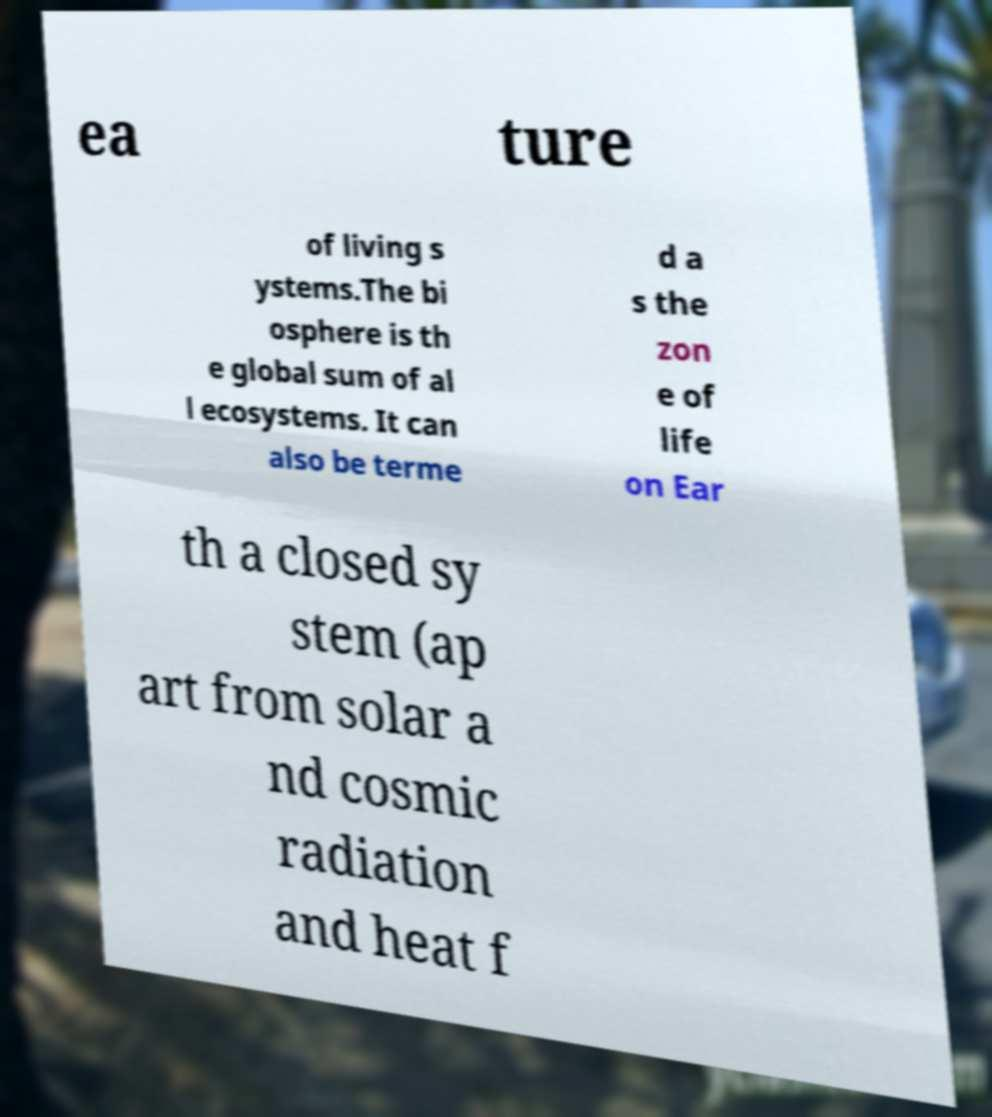I need the written content from this picture converted into text. Can you do that? ea ture of living s ystems.The bi osphere is th e global sum of al l ecosystems. It can also be terme d a s the zon e of life on Ear th a closed sy stem (ap art from solar a nd cosmic radiation and heat f 